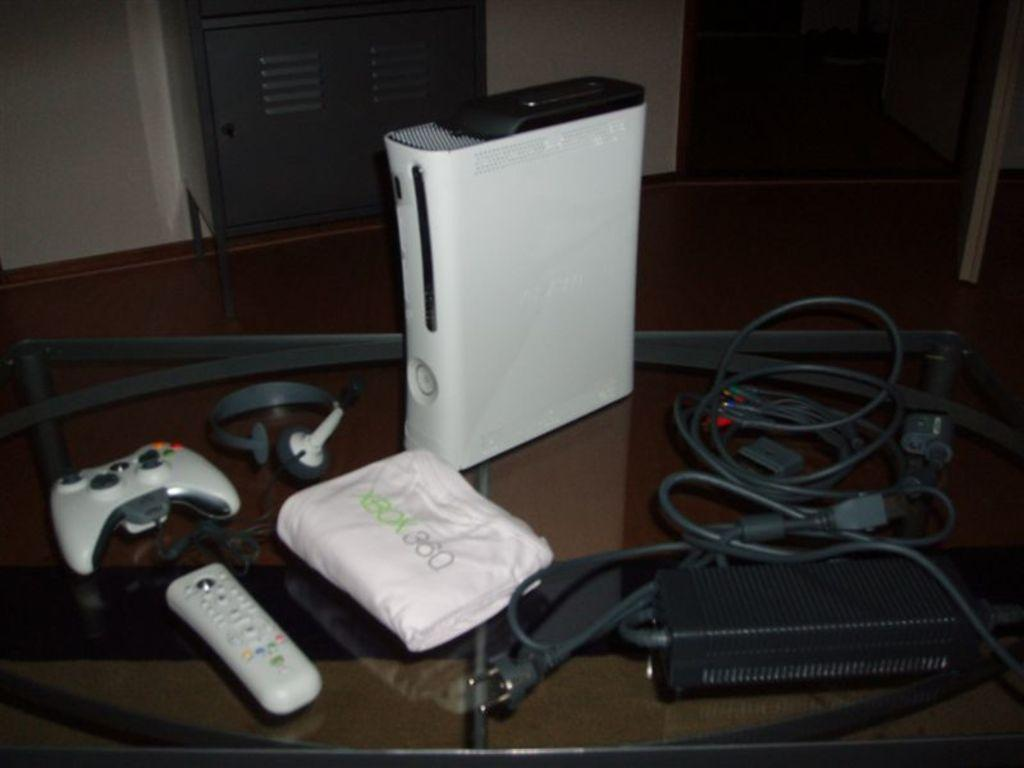Provide a one-sentence caption for the provided image. On a glass table sits a complete XBOX 360 gaming system. 